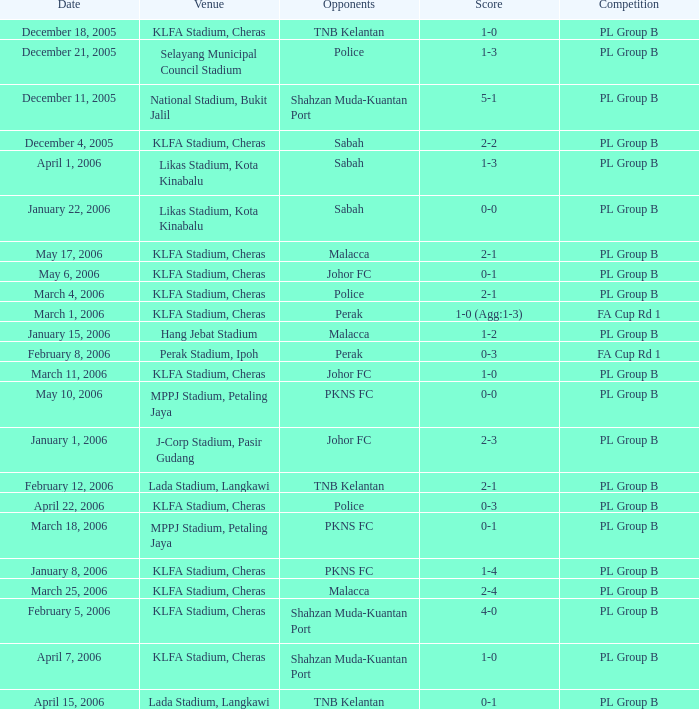Who participated in the competition on may 6, 2006? Johor FC. 